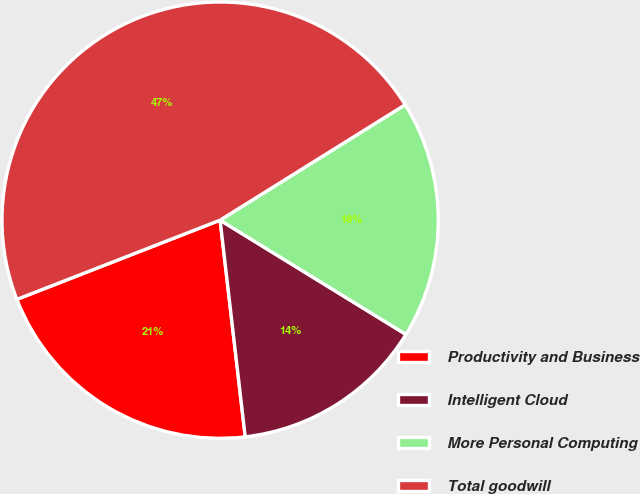Convert chart to OTSL. <chart><loc_0><loc_0><loc_500><loc_500><pie_chart><fcel>Productivity and Business<fcel>Intelligent Cloud<fcel>More Personal Computing<fcel>Total goodwill<nl><fcel>20.92%<fcel>14.39%<fcel>17.65%<fcel>47.04%<nl></chart> 